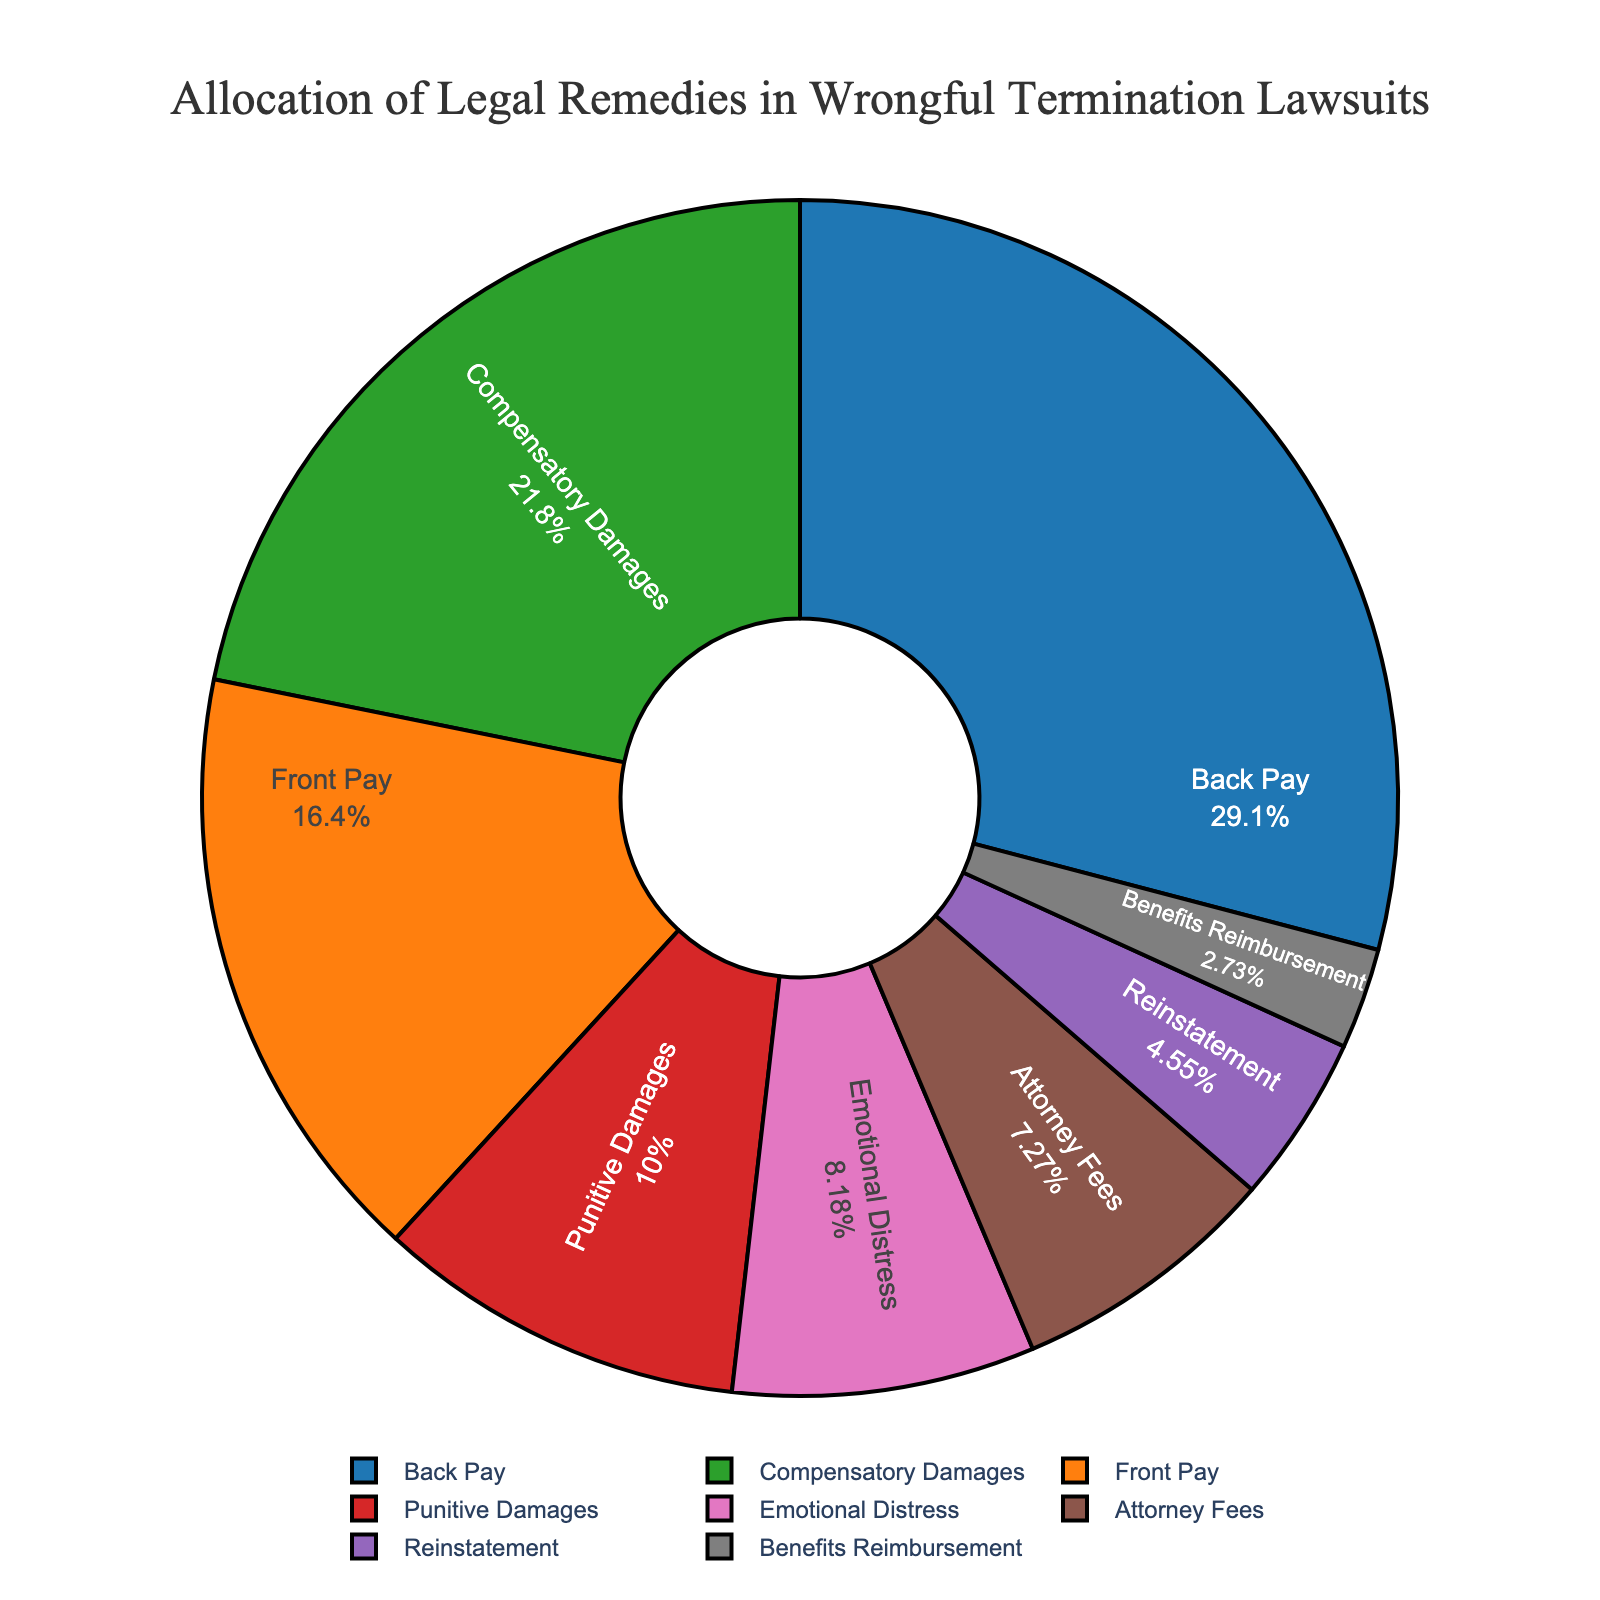What is the most frequently awarded remedy? By examining the percentages in the pie chart, we see that "Back Pay" has the highest percentage, which is 32%.
Answer: Back Pay Which remedy is awarded more frequently: Compensatory Damages or Front Pay? Compensatory Damages have a percentage of 24% and Front Pay has a percentage of 18%. Since 24% is greater than 18%, Compensatory Damages are awarded more frequently.
Answer: Compensatory Damages What is the combined percentage of Attorney Fees and Emotional Distress awards? Adding the percentages for Attorney Fees (8%) and Emotional Distress (9%) gives us 8% + 9% = 17%.
Answer: 17% What remedies make up less than 10% each of the total awards? The remedies with less than 10% each are Emotional Distress (9%), Punitive Damages (11%), Reinstatement (5%), and Benefits Reimbursement (3%). Only Emotional Distress and Benefits Reimbursement meet the criteria of less than 10%.
Answer: Reinstatement, Benefits Reimbursement How much more is allocated to Back Pay compared to Emotional Distress? The percentage for Back Pay is 32% and for Emotional Distress is 9%. So, 32% - 9% = 23% more is allocated to Back Pay.
Answer: 23% Which remedy has the smallest allocation and what is its percentage? By examining the pie chart, we see that "Benefits Reimbursement" has the smallest allocation at 3%.
Answer: Benefits Reimbursement, 3% List the remedies in descending order of their allocation. The order from highest to lowest percentage is: Back Pay (32%), Compensatory Damages (24%), Front Pay (18%), Attorney Fees (8%), Emotional Distress (9%), Punitive Damages (11%), Reinstatement (5%), Benefits Reimbursement (3%).
Answer: Back Pay, Compensatory Damages, Front Pay, Punitive Damages, Emotional Distress, Attorney Fees, Reinstatement, Benefits Reimbursement What percentage of the awards is made up by compensatory damages and punitive damages combined? Adding the percentages for Compensatory Damages (24%) and Punitive Damages (11%) gives us 24% + 11% = 35%.
Answer: 35% How does the allocation of Reinstatement compare to Attorney Fees? Reinstatement has a percentage of 5% while Attorney Fees have 8%. Since 5% is less than 8%, Reinstatement has a smaller allocation than Attorney Fees.
Answer: Reinstatement has a smaller allocation 